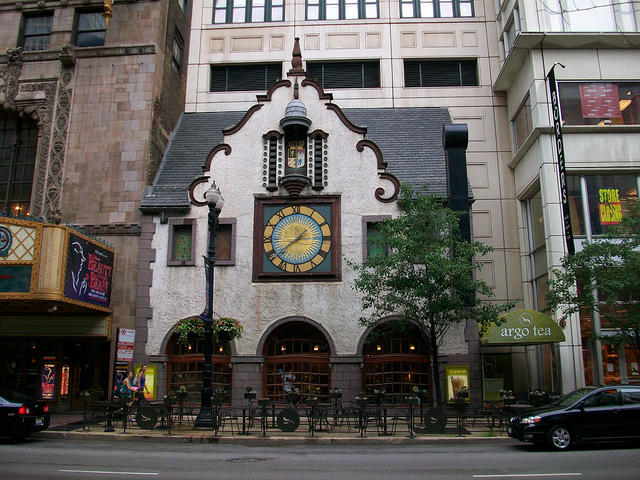Extract all visible text content from this image. tea argo STORE XI X 